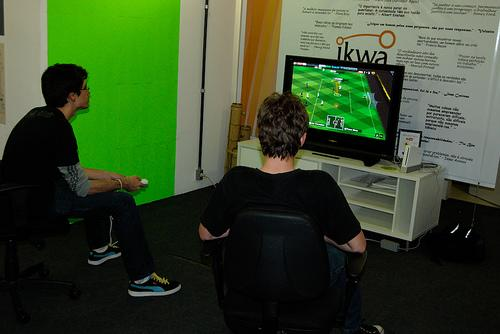What is the white thing the man is holding?

Choices:
A) napkin
B) lighter
C) game remote
D) phone game remote 